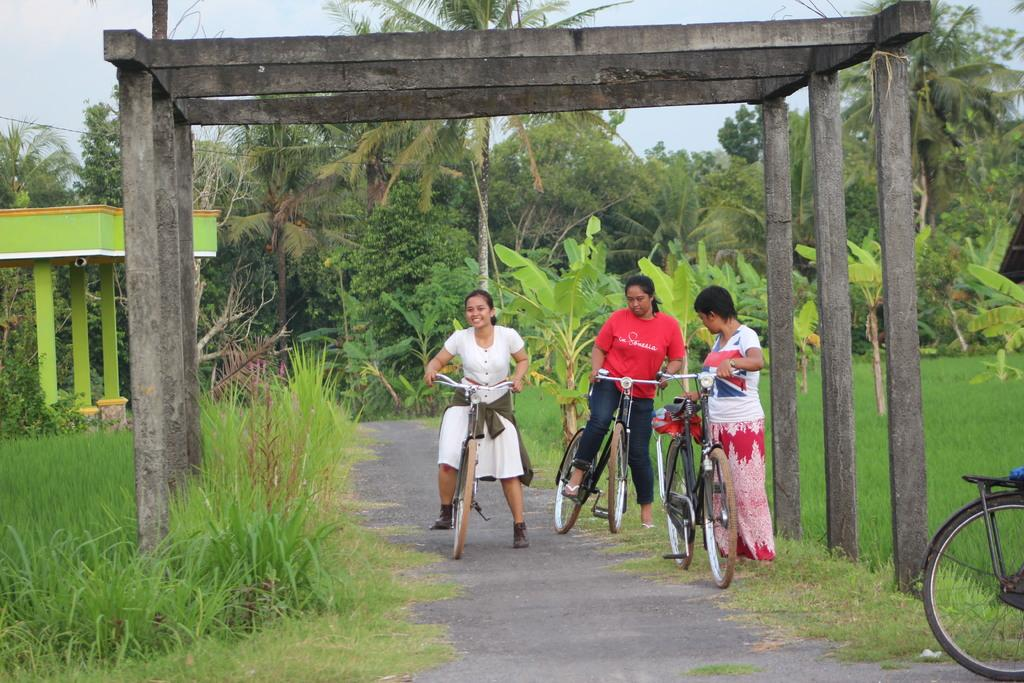How many girls are in the image? There are three girls in the image. What are the girls holding in the image? The girls are holding bicycles. Can you describe the facial expression of one of the girls? One of the girls has a pretty smile on her face. What can be seen on the right side of the image? There is a farm on the right side of the image. What type of vegetation is visible in the background of the image? There are trees in the background of the image. What type of company is the girls trying to promote in the image? There is no indication in the image that the girls are trying to promote any company. 